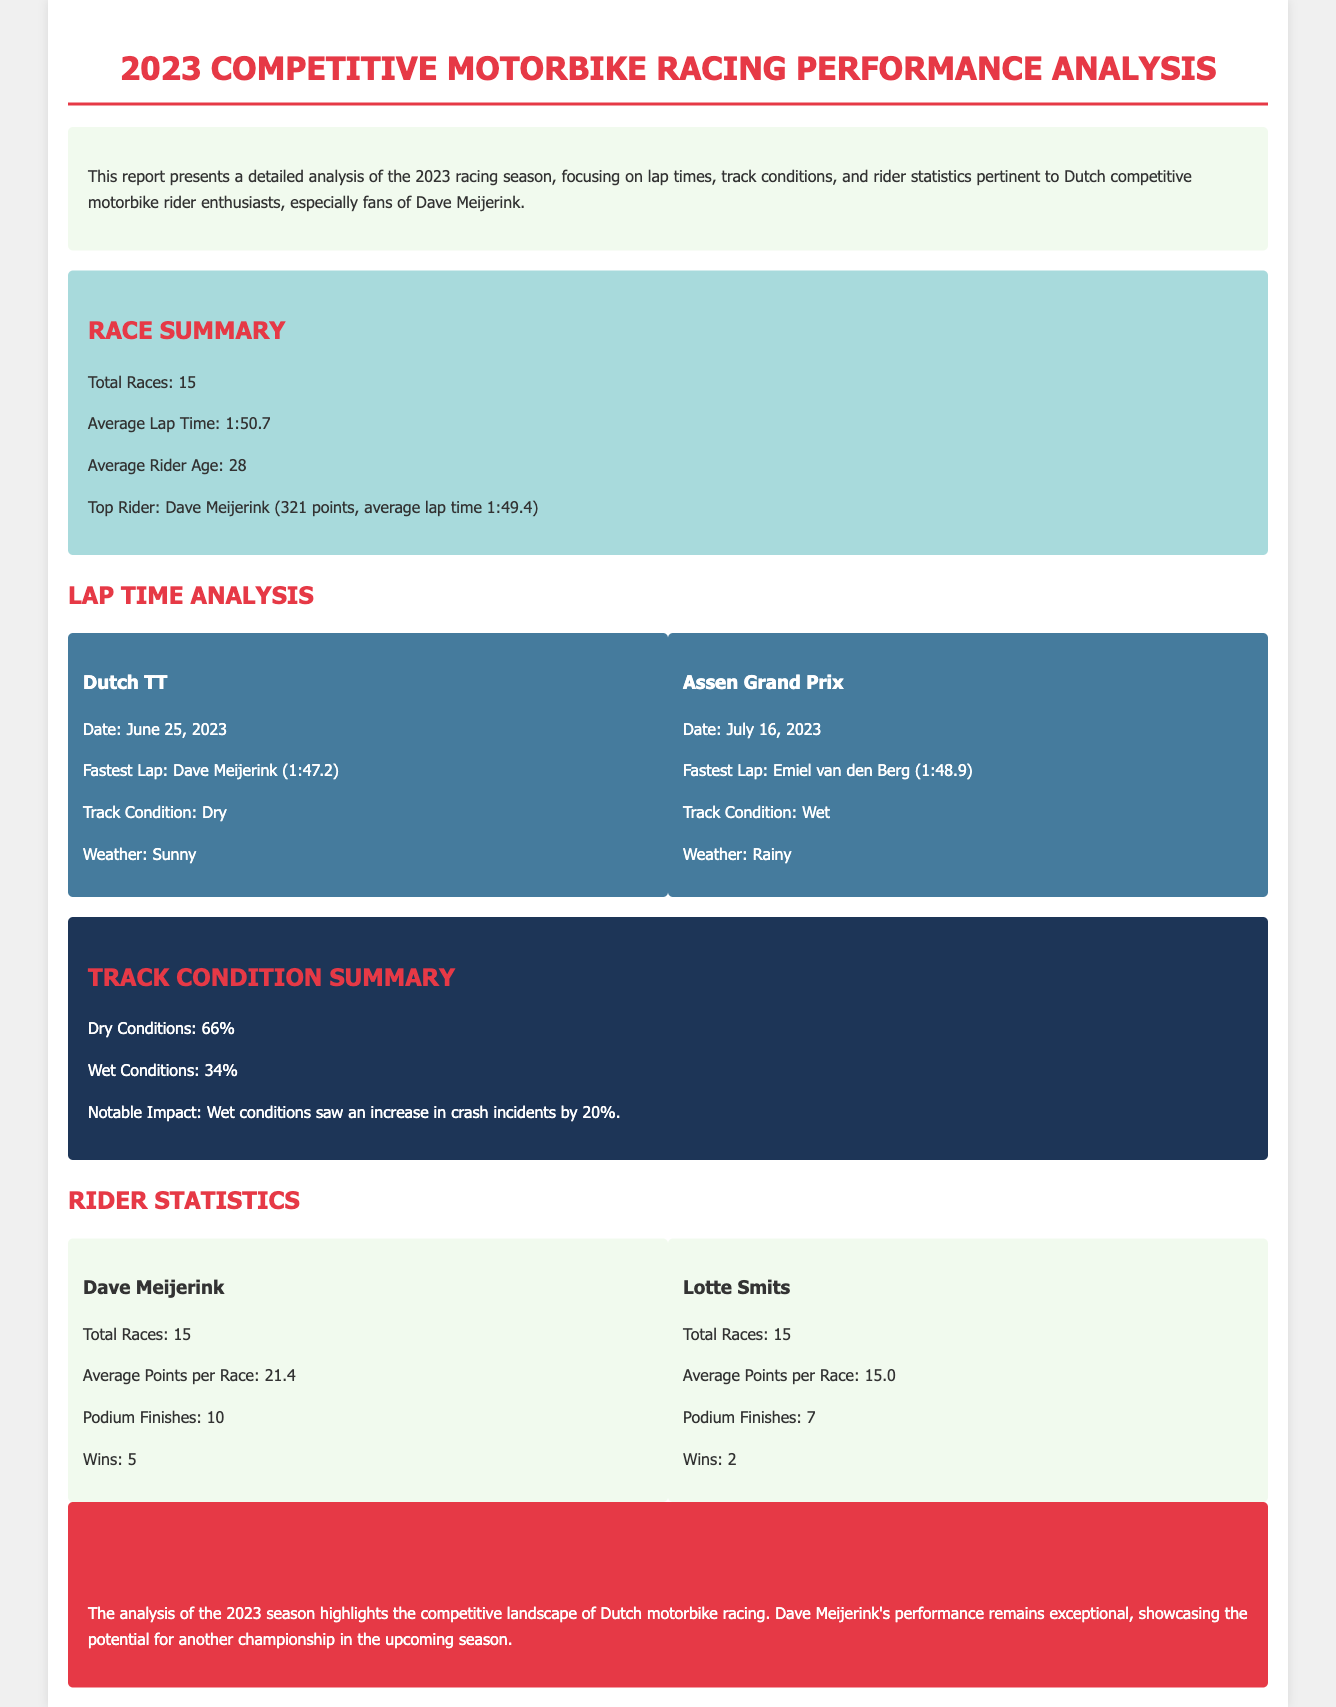What is the title of the report? The title is mentioned at the top of the document as "2023 Competitive Motorbike Racing Performance Analysis."
Answer: 2023 Competitive Motorbike Racing Performance Analysis How many total races were there in the season? The total number of races is stated in the report, specifically in the race summary section.
Answer: 15 Who had the fastest lap in the Dutch TT? The report provides the fastest lap for the Dutch TT, including the rider's name.
Answer: Dave Meijerink What was the average lap time during the season? The average lap time is included in the race summary, giving a clear metric of overall performance.
Answer: 1:50.7 What percentage of races were held under dry conditions? The track condition summary lists the percentage of dry conditions directly.
Answer: 66% How many podium finishes did Lotte Smits achieve? The document specifies the podium finishes for each rider, including Lotte Smits.
Answer: 7 What was the notable impact of wet conditions mentioned in the report? The report includes a specific detail about the consequences of wet conditions on racing.
Answer: Increase in crash incidents by 20% What is Dave Meijerink's average points per race? This information is contained in the rider statistics section, providing key performance metrics.
Answer: 21.4 Who is the top rider according to the report? The report explicitly mentions the top rider in the race summary section.
Answer: Dave Meijerink 